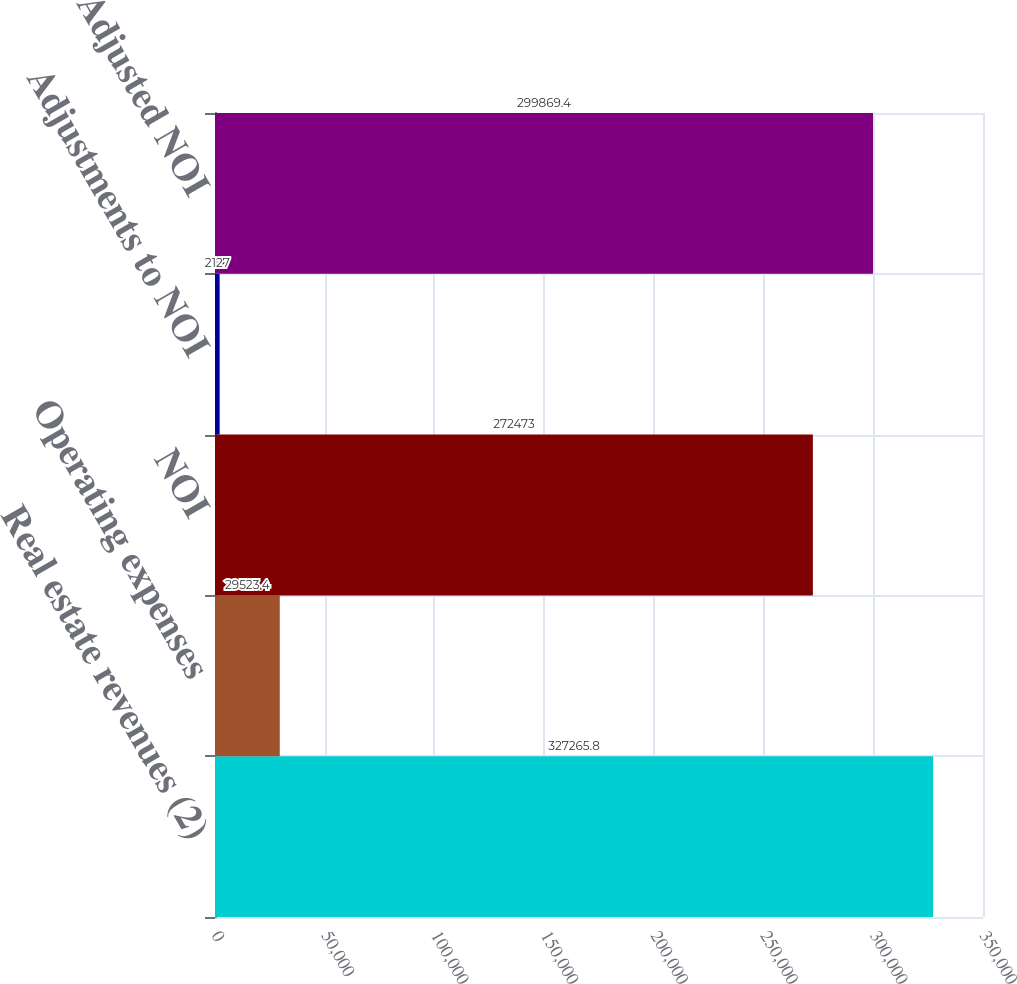Convert chart. <chart><loc_0><loc_0><loc_500><loc_500><bar_chart><fcel>Real estate revenues (2)<fcel>Operating expenses<fcel>NOI<fcel>Adjustments to NOI<fcel>Adjusted NOI<nl><fcel>327266<fcel>29523.4<fcel>272473<fcel>2127<fcel>299869<nl></chart> 